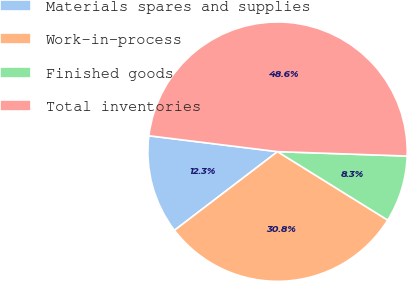<chart> <loc_0><loc_0><loc_500><loc_500><pie_chart><fcel>Materials spares and supplies<fcel>Work-in-process<fcel>Finished goods<fcel>Total inventories<nl><fcel>12.33%<fcel>30.78%<fcel>8.31%<fcel>48.59%<nl></chart> 